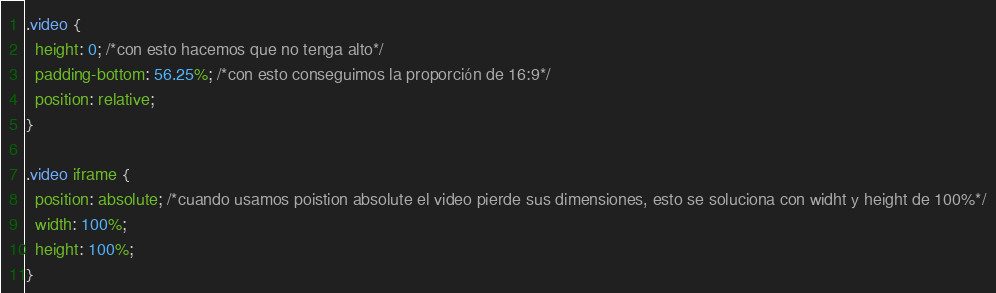<code> <loc_0><loc_0><loc_500><loc_500><_CSS_>
.video {
  height: 0; /*con esto hacemos que no tenga alto*/
  padding-bottom: 56.25%; /*con esto conseguimos la proporción de 16:9*/
  position: relative;
}

.video iframe {
  position: absolute; /*cuando usamos poistion absolute el video pierde sus dimensiones, esto se soluciona con widht y height de 100%*/
  width: 100%;
  height: 100%;
}
</code> 